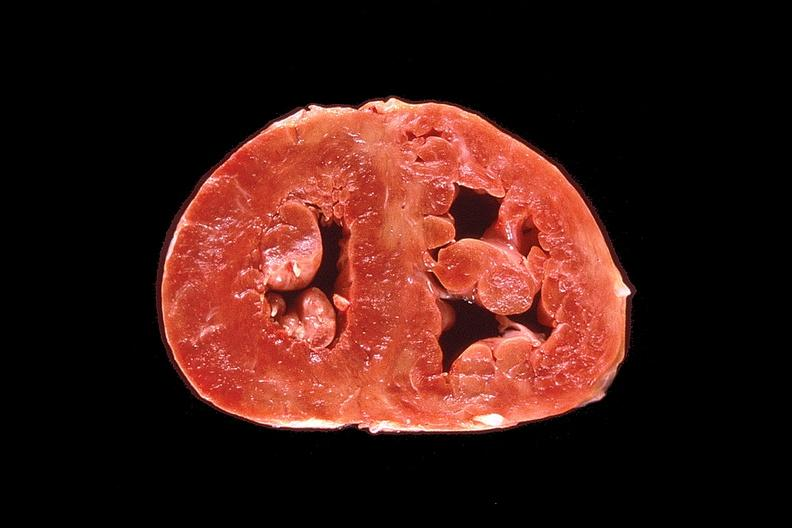s cardiovascular present?
Answer the question using a single word or phrase. Yes 